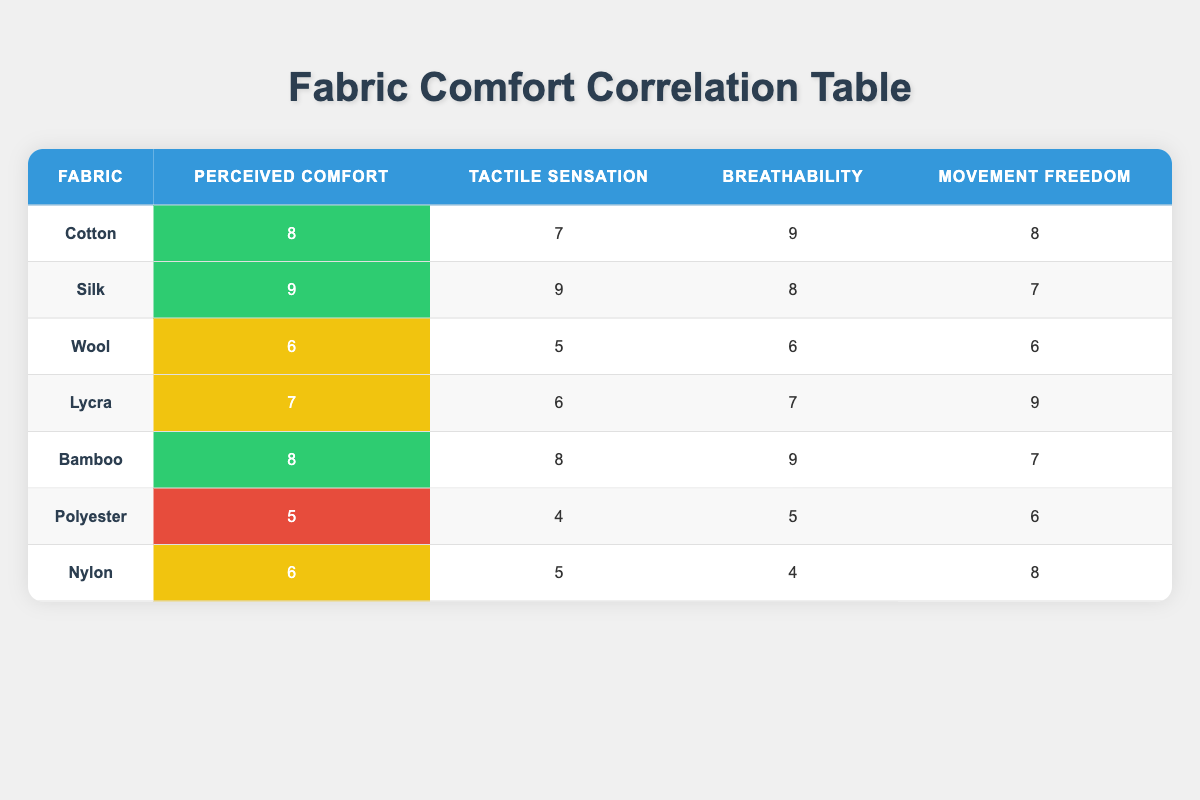What is the perceived comfort rating of Cotton? Referring to the table, under the "Perceived Comfort" column for the row corresponding to "Cotton", the value is 8.
Answer: 8 Which fabric has the highest breathability score? In the "Breathability" column, the highest score is 9, which corresponds to both "Cotton" and "Bamboo".
Answer: Cotton and Bamboo Is the tactile sensation of Polyester greater than that of Wool? Comparing the "Tactile Sensation" scores, Polyester has a value of 4 while Wool has a value of 5. Since 4 is less than 5, the statement is false.
Answer: No What is the average perceived comfort rating of the fabrics listed? To calculate the average, add the perceived comfort ratings: 8 + 9 + 6 + 7 + 8 + 5 + 6 = 49. There are 7 fabrics, so the average is 49/7 = 7.
Answer: 7 Does Bamboo provide a higher movement freedom score than Silk? Looking at the "Movement Freedom" scores, Bamboo has a score of 7 while Silk has a score of 7 as well. Since neither is higher, the answer is no.
Answer: No What is the sum of the perceived comfort scores for Cotton and Silk? The perceived comfort score for Cotton is 8 and for Silk is 9. Therefore, the sum is 8 + 9 = 17.
Answer: 17 Which fabric has both the lowest perceived comfort and the lowest tactile sensation scores? Polyester has a perceived comfort score of 5 and a tactile sensation score of 4; both are the lowest in their respective categories. Therefore, Polyester is the answer.
Answer: Polyester How much higher is the breathability score of Bamboo compared to Polyester? The score for Bamboo is 9 and the score for Polyester is 5. To find the difference, subtract 5 from 9 which gives 4.
Answer: 4 Is there any fabric with a perceived comfort rating of 9? Yes, by checking the "Perceived Comfort" column, both Cotton and Silk have a score of 9. Therefore, the answer is yes.
Answer: Yes 